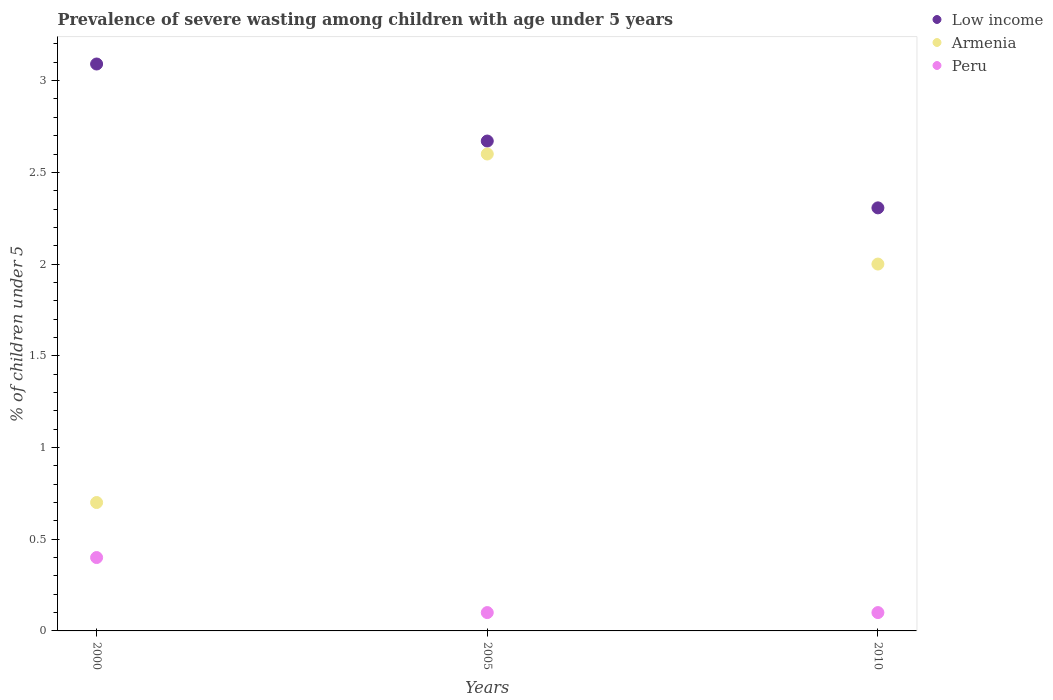How many different coloured dotlines are there?
Make the answer very short. 3. Is the number of dotlines equal to the number of legend labels?
Ensure brevity in your answer.  Yes. What is the percentage of severely wasted children in Peru in 2000?
Offer a terse response. 0.4. Across all years, what is the maximum percentage of severely wasted children in Armenia?
Provide a succinct answer. 2.6. Across all years, what is the minimum percentage of severely wasted children in Armenia?
Provide a succinct answer. 0.7. In which year was the percentage of severely wasted children in Peru minimum?
Provide a succinct answer. 2005. What is the total percentage of severely wasted children in Peru in the graph?
Your response must be concise. 0.6. What is the difference between the percentage of severely wasted children in Low income in 2000 and that in 2010?
Ensure brevity in your answer.  0.78. What is the difference between the percentage of severely wasted children in Low income in 2000 and the percentage of severely wasted children in Peru in 2010?
Offer a very short reply. 2.99. What is the average percentage of severely wasted children in Armenia per year?
Your response must be concise. 1.77. In the year 2010, what is the difference between the percentage of severely wasted children in Armenia and percentage of severely wasted children in Low income?
Your answer should be very brief. -0.31. What is the ratio of the percentage of severely wasted children in Armenia in 2005 to that in 2010?
Offer a very short reply. 1.3. What is the difference between the highest and the second highest percentage of severely wasted children in Peru?
Make the answer very short. 0.3. What is the difference between the highest and the lowest percentage of severely wasted children in Peru?
Provide a short and direct response. 0.3. In how many years, is the percentage of severely wasted children in Low income greater than the average percentage of severely wasted children in Low income taken over all years?
Your response must be concise. 1. Is the sum of the percentage of severely wasted children in Peru in 2000 and 2005 greater than the maximum percentage of severely wasted children in Armenia across all years?
Keep it short and to the point. No. Is it the case that in every year, the sum of the percentage of severely wasted children in Low income and percentage of severely wasted children in Armenia  is greater than the percentage of severely wasted children in Peru?
Your response must be concise. Yes. Is the percentage of severely wasted children in Low income strictly greater than the percentage of severely wasted children in Peru over the years?
Ensure brevity in your answer.  Yes. What is the difference between two consecutive major ticks on the Y-axis?
Provide a short and direct response. 0.5. Are the values on the major ticks of Y-axis written in scientific E-notation?
Your response must be concise. No. What is the title of the graph?
Provide a succinct answer. Prevalence of severe wasting among children with age under 5 years. What is the label or title of the Y-axis?
Give a very brief answer. % of children under 5. What is the % of children under 5 in Low income in 2000?
Provide a short and direct response. 3.09. What is the % of children under 5 of Armenia in 2000?
Your answer should be compact. 0.7. What is the % of children under 5 of Peru in 2000?
Offer a very short reply. 0.4. What is the % of children under 5 in Low income in 2005?
Give a very brief answer. 2.67. What is the % of children under 5 in Armenia in 2005?
Offer a very short reply. 2.6. What is the % of children under 5 in Peru in 2005?
Provide a short and direct response. 0.1. What is the % of children under 5 in Low income in 2010?
Your answer should be very brief. 2.31. What is the % of children under 5 in Armenia in 2010?
Your response must be concise. 2. What is the % of children under 5 of Peru in 2010?
Offer a very short reply. 0.1. Across all years, what is the maximum % of children under 5 in Low income?
Make the answer very short. 3.09. Across all years, what is the maximum % of children under 5 of Armenia?
Ensure brevity in your answer.  2.6. Across all years, what is the maximum % of children under 5 of Peru?
Your answer should be compact. 0.4. Across all years, what is the minimum % of children under 5 of Low income?
Make the answer very short. 2.31. Across all years, what is the minimum % of children under 5 of Armenia?
Offer a terse response. 0.7. Across all years, what is the minimum % of children under 5 in Peru?
Your response must be concise. 0.1. What is the total % of children under 5 of Low income in the graph?
Make the answer very short. 8.07. What is the total % of children under 5 in Peru in the graph?
Make the answer very short. 0.6. What is the difference between the % of children under 5 in Low income in 2000 and that in 2005?
Provide a short and direct response. 0.42. What is the difference between the % of children under 5 of Armenia in 2000 and that in 2005?
Make the answer very short. -1.9. What is the difference between the % of children under 5 in Low income in 2000 and that in 2010?
Make the answer very short. 0.78. What is the difference between the % of children under 5 of Armenia in 2000 and that in 2010?
Make the answer very short. -1.3. What is the difference between the % of children under 5 of Peru in 2000 and that in 2010?
Keep it short and to the point. 0.3. What is the difference between the % of children under 5 of Low income in 2005 and that in 2010?
Provide a short and direct response. 0.36. What is the difference between the % of children under 5 in Armenia in 2005 and that in 2010?
Make the answer very short. 0.6. What is the difference between the % of children under 5 in Peru in 2005 and that in 2010?
Your response must be concise. 0. What is the difference between the % of children under 5 of Low income in 2000 and the % of children under 5 of Armenia in 2005?
Provide a short and direct response. 0.49. What is the difference between the % of children under 5 in Low income in 2000 and the % of children under 5 in Peru in 2005?
Offer a terse response. 2.99. What is the difference between the % of children under 5 in Armenia in 2000 and the % of children under 5 in Peru in 2005?
Make the answer very short. 0.6. What is the difference between the % of children under 5 in Low income in 2000 and the % of children under 5 in Armenia in 2010?
Provide a succinct answer. 1.09. What is the difference between the % of children under 5 of Low income in 2000 and the % of children under 5 of Peru in 2010?
Ensure brevity in your answer.  2.99. What is the difference between the % of children under 5 in Armenia in 2000 and the % of children under 5 in Peru in 2010?
Give a very brief answer. 0.6. What is the difference between the % of children under 5 in Low income in 2005 and the % of children under 5 in Armenia in 2010?
Your answer should be very brief. 0.67. What is the difference between the % of children under 5 of Low income in 2005 and the % of children under 5 of Peru in 2010?
Your answer should be compact. 2.57. What is the difference between the % of children under 5 in Armenia in 2005 and the % of children under 5 in Peru in 2010?
Make the answer very short. 2.5. What is the average % of children under 5 of Low income per year?
Make the answer very short. 2.69. What is the average % of children under 5 of Armenia per year?
Give a very brief answer. 1.77. In the year 2000, what is the difference between the % of children under 5 of Low income and % of children under 5 of Armenia?
Offer a very short reply. 2.39. In the year 2000, what is the difference between the % of children under 5 in Low income and % of children under 5 in Peru?
Provide a succinct answer. 2.69. In the year 2005, what is the difference between the % of children under 5 in Low income and % of children under 5 in Armenia?
Your response must be concise. 0.07. In the year 2005, what is the difference between the % of children under 5 in Low income and % of children under 5 in Peru?
Ensure brevity in your answer.  2.57. In the year 2010, what is the difference between the % of children under 5 in Low income and % of children under 5 in Armenia?
Provide a succinct answer. 0.31. In the year 2010, what is the difference between the % of children under 5 in Low income and % of children under 5 in Peru?
Provide a succinct answer. 2.21. In the year 2010, what is the difference between the % of children under 5 of Armenia and % of children under 5 of Peru?
Your answer should be very brief. 1.9. What is the ratio of the % of children under 5 of Low income in 2000 to that in 2005?
Your response must be concise. 1.16. What is the ratio of the % of children under 5 in Armenia in 2000 to that in 2005?
Provide a succinct answer. 0.27. What is the ratio of the % of children under 5 in Low income in 2000 to that in 2010?
Provide a short and direct response. 1.34. What is the ratio of the % of children under 5 in Peru in 2000 to that in 2010?
Ensure brevity in your answer.  4. What is the ratio of the % of children under 5 in Low income in 2005 to that in 2010?
Keep it short and to the point. 1.16. What is the difference between the highest and the second highest % of children under 5 in Low income?
Provide a short and direct response. 0.42. What is the difference between the highest and the lowest % of children under 5 of Low income?
Your response must be concise. 0.78. What is the difference between the highest and the lowest % of children under 5 in Armenia?
Your response must be concise. 1.9. 